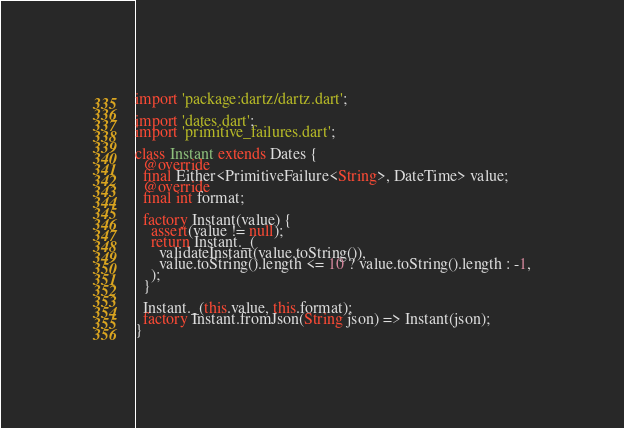<code> <loc_0><loc_0><loc_500><loc_500><_Dart_>import 'package:dartz/dartz.dart';

import 'dates.dart';
import 'primitive_failures.dart';

class Instant extends Dates {
  @override
  final Either<PrimitiveFailure<String>, DateTime> value;
  @override
  final int format;

  factory Instant(value) {
    assert(value != null);
    return Instant._(
      validateInstant(value.toString()),
      value.toString().length <= 10 ? value.toString().length : -1,
    );
  }

  Instant._(this.value, this.format);
  factory Instant.fromJson(String json) => Instant(json);
}
</code> 